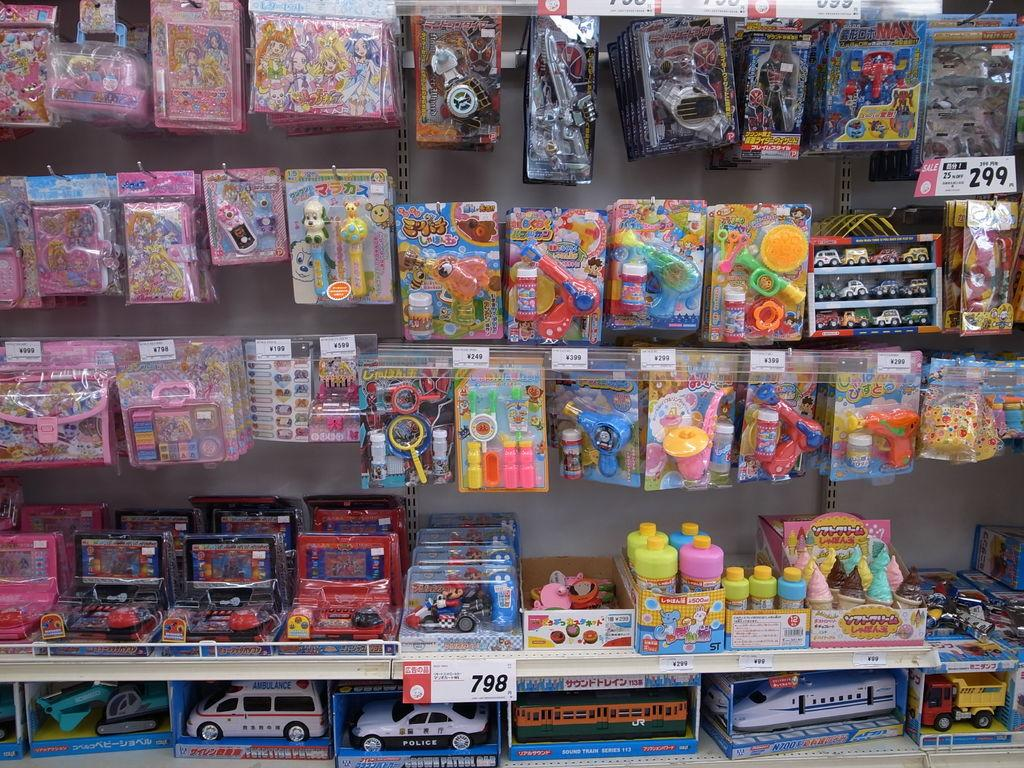Provide a one-sentence caption for the provided image. a group of toys and one that has ambulance written on it. 